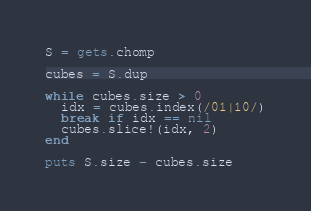<code> <loc_0><loc_0><loc_500><loc_500><_Ruby_>S = gets.chomp

cubes = S.dup

while cubes.size > 0
  idx = cubes.index(/01|10/)
  break if idx == nil
  cubes.slice!(idx, 2)
end

puts S.size - cubes.size</code> 